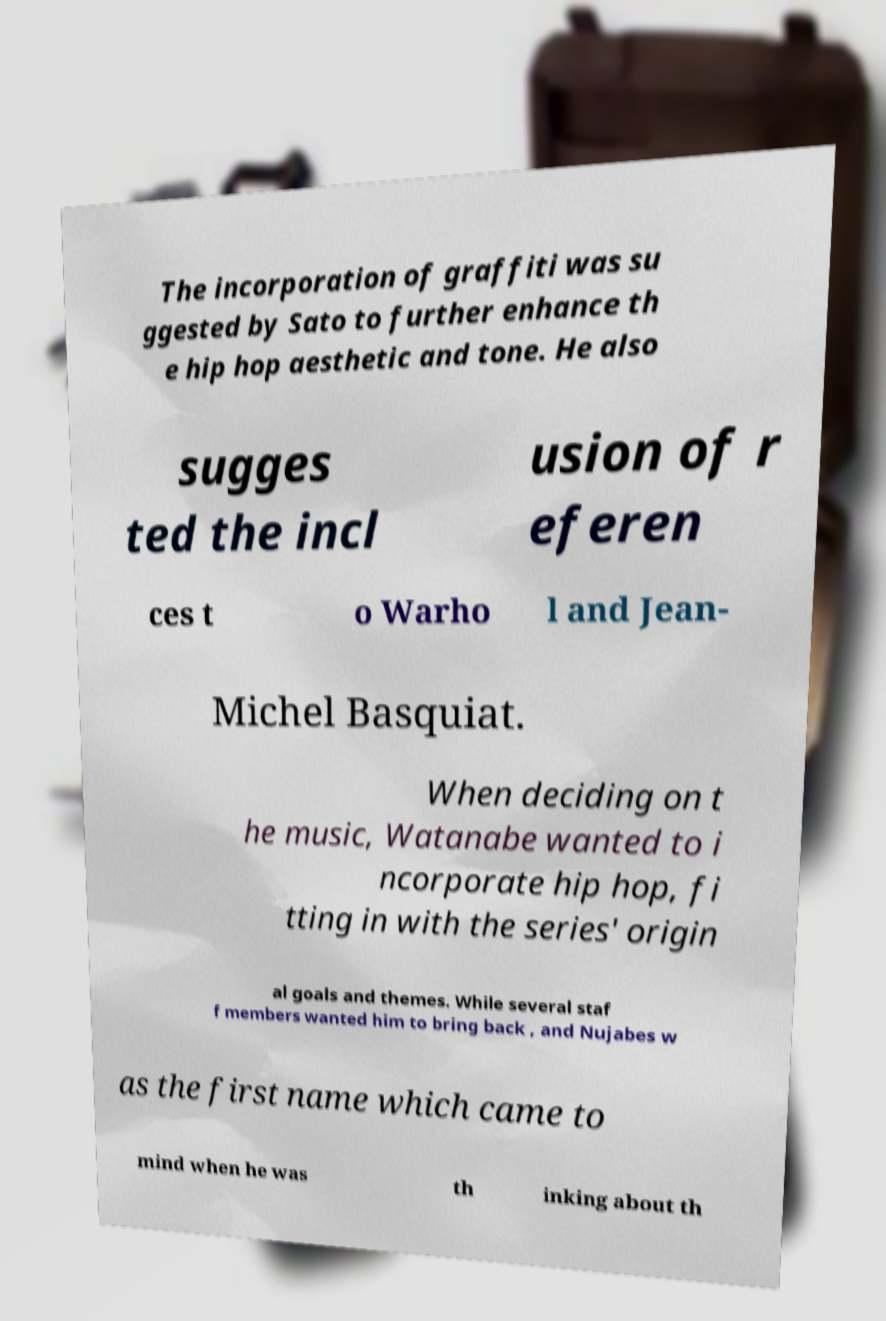There's text embedded in this image that I need extracted. Can you transcribe it verbatim? The incorporation of graffiti was su ggested by Sato to further enhance th e hip hop aesthetic and tone. He also sugges ted the incl usion of r eferen ces t o Warho l and Jean- Michel Basquiat. When deciding on t he music, Watanabe wanted to i ncorporate hip hop, fi tting in with the series' origin al goals and themes. While several staf f members wanted him to bring back , and Nujabes w as the first name which came to mind when he was th inking about th 